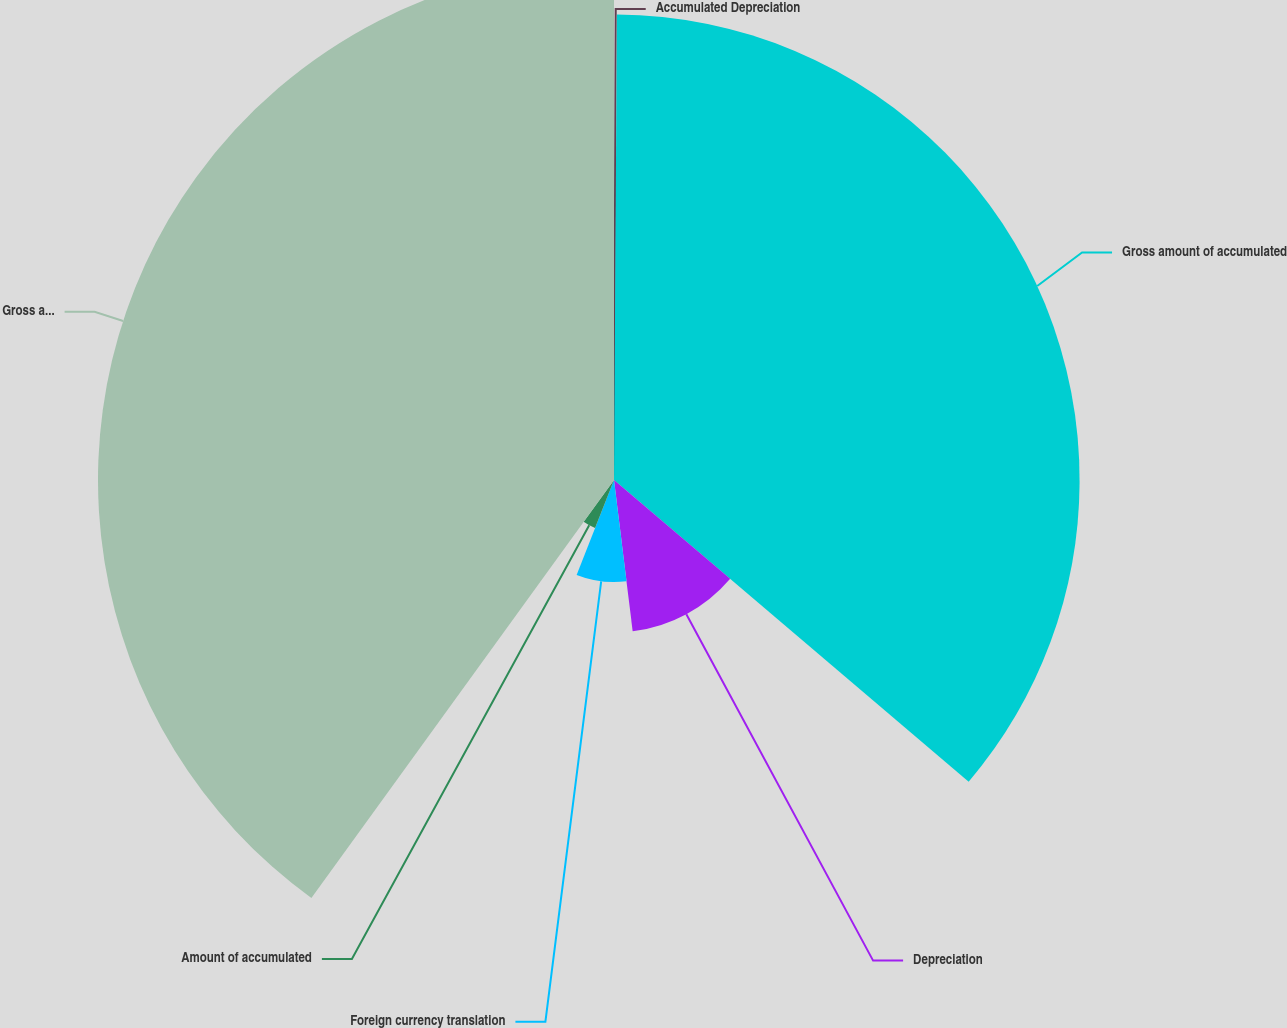<chart> <loc_0><loc_0><loc_500><loc_500><pie_chart><fcel>Accumulated Depreciation<fcel>Gross amount of accumulated<fcel>Depreciation<fcel>Foreign currency translation<fcel>Amount of accumulated<fcel>Gross amount of end of period<nl><fcel>0.1%<fcel>36.12%<fcel>11.83%<fcel>7.92%<fcel>4.01%<fcel>40.03%<nl></chart> 